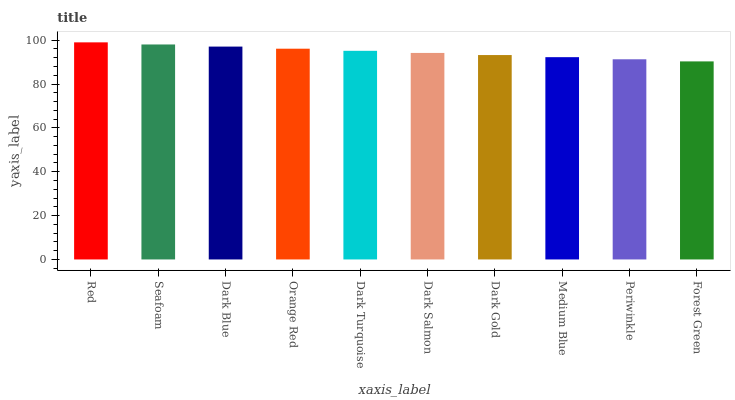Is Forest Green the minimum?
Answer yes or no. Yes. Is Red the maximum?
Answer yes or no. Yes. Is Seafoam the minimum?
Answer yes or no. No. Is Seafoam the maximum?
Answer yes or no. No. Is Red greater than Seafoam?
Answer yes or no. Yes. Is Seafoam less than Red?
Answer yes or no. Yes. Is Seafoam greater than Red?
Answer yes or no. No. Is Red less than Seafoam?
Answer yes or no. No. Is Dark Turquoise the high median?
Answer yes or no. Yes. Is Dark Salmon the low median?
Answer yes or no. Yes. Is Dark Salmon the high median?
Answer yes or no. No. Is Seafoam the low median?
Answer yes or no. No. 